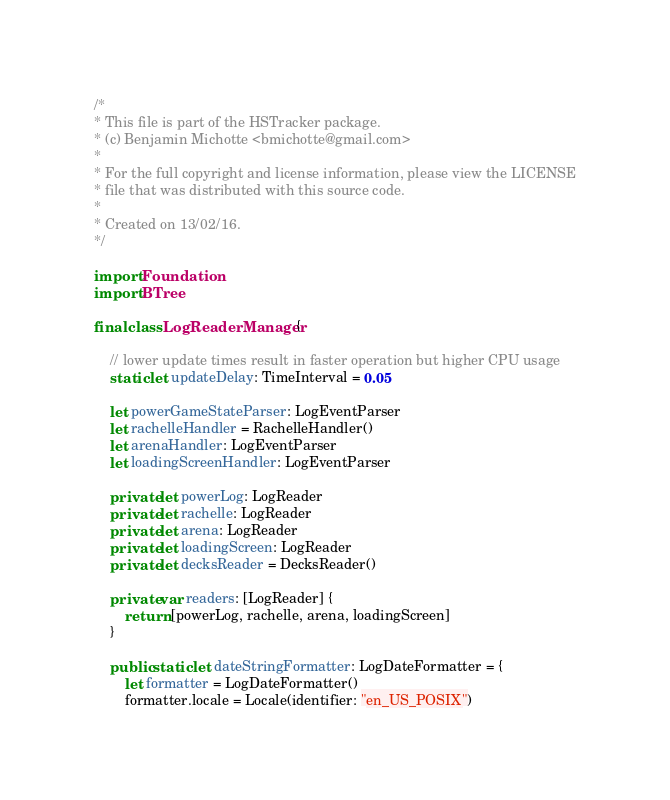Convert code to text. <code><loc_0><loc_0><loc_500><loc_500><_Swift_>/*
* This file is part of the HSTracker package.
* (c) Benjamin Michotte <bmichotte@gmail.com>
*
* For the full copyright and license information, please view the LICENSE
* file that was distributed with this source code.
*
* Created on 13/02/16.
*/

import Foundation
import BTree

final class LogReaderManager {
	
    // lower update times result in faster operation but higher CPU usage
	static let updateDelay: TimeInterval = 0.05
	
    let powerGameStateParser: LogEventParser
    let rachelleHandler = RachelleHandler()
	let arenaHandler: LogEventParser
	let loadingScreenHandler: LogEventParser

    private let powerLog: LogReader
    private let rachelle: LogReader
    private let arena: LogReader
    private let loadingScreen: LogReader
    private let decksReader = DecksReader()

    private var readers: [LogReader] {
        return [powerLog, rachelle, arena, loadingScreen]
    }
    
    public static let dateStringFormatter: LogDateFormatter = {
        let formatter = LogDateFormatter()
        formatter.locale = Locale(identifier: "en_US_POSIX")</code> 